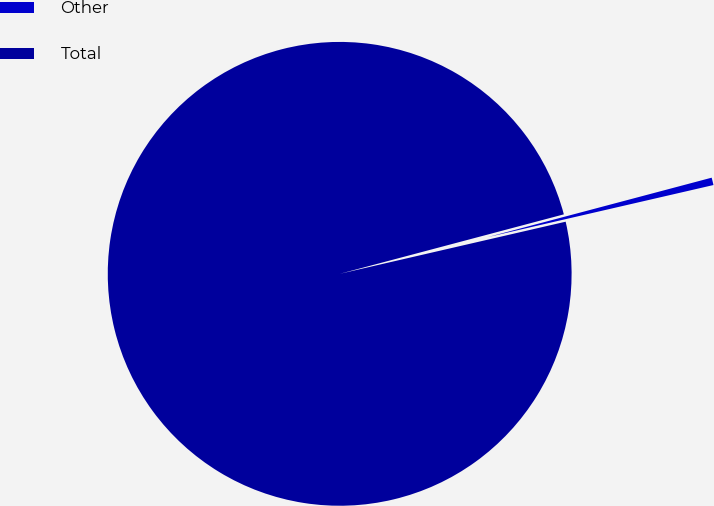Convert chart to OTSL. <chart><loc_0><loc_0><loc_500><loc_500><pie_chart><fcel>Other<fcel>Total<nl><fcel>0.52%<fcel>99.48%<nl></chart> 